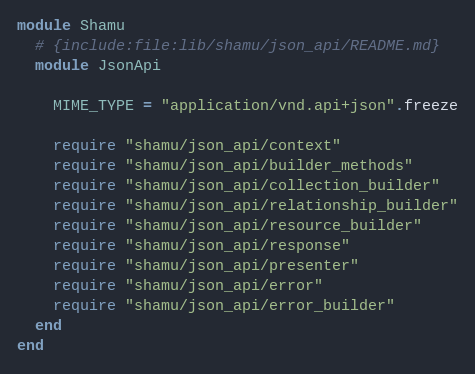Convert code to text. <code><loc_0><loc_0><loc_500><loc_500><_Ruby_>module Shamu
  # {include:file:lib/shamu/json_api/README.md}
  module JsonApi

    MIME_TYPE = "application/vnd.api+json".freeze

    require "shamu/json_api/context"
    require "shamu/json_api/builder_methods"
    require "shamu/json_api/collection_builder"
    require "shamu/json_api/relationship_builder"
    require "shamu/json_api/resource_builder"
    require "shamu/json_api/response"
    require "shamu/json_api/presenter"
    require "shamu/json_api/error"
    require "shamu/json_api/error_builder"
  end
end</code> 